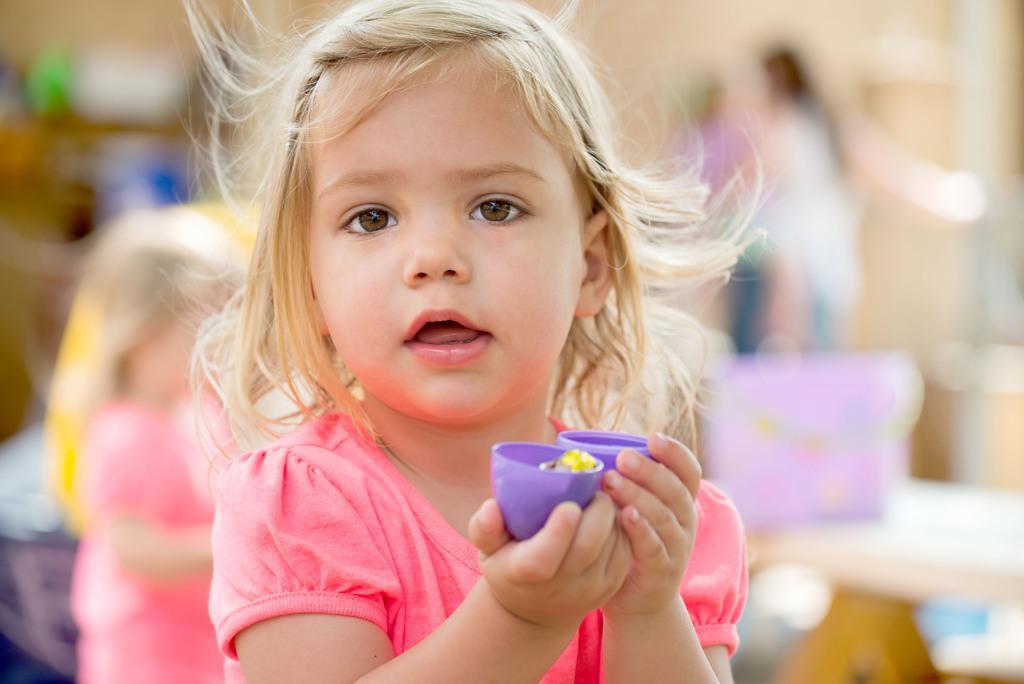Please provide a concise description of this image. In this image we can see a kid holding some objects and the background is blurred. 